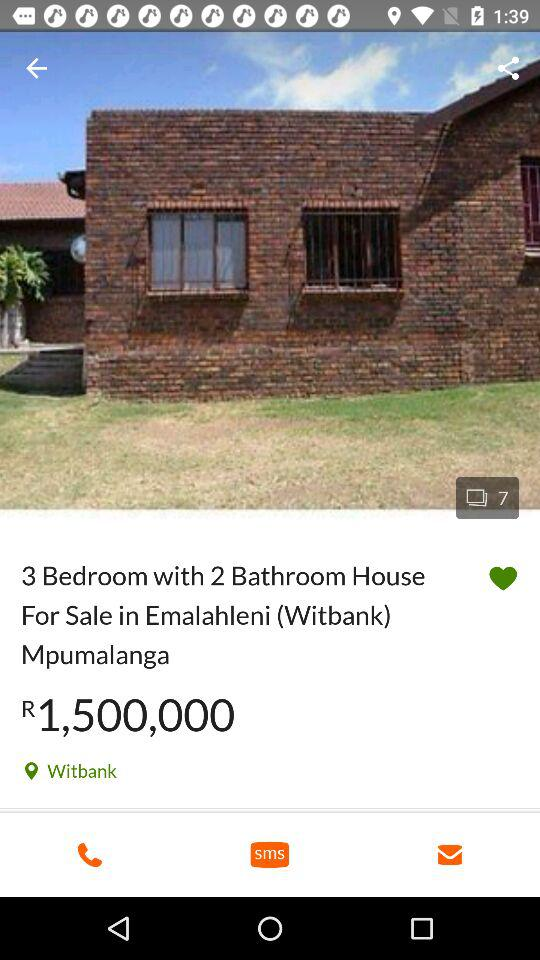What is the current location of the house? The current location is Witbank. 